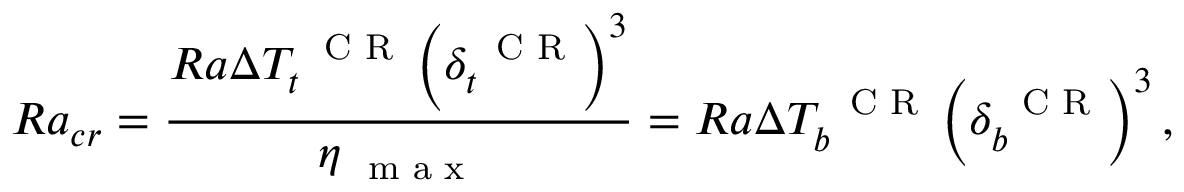<formula> <loc_0><loc_0><loc_500><loc_500>R a _ { c r } = \frac { R a \Delta T _ { t } ^ { C R } \left ( \delta _ { t } ^ { C R } \right ) ^ { 3 } } { \eta _ { m a x } } = R a \Delta T _ { b } ^ { C R } \left ( \delta _ { b } ^ { C R } \right ) ^ { 3 } ,</formula> 